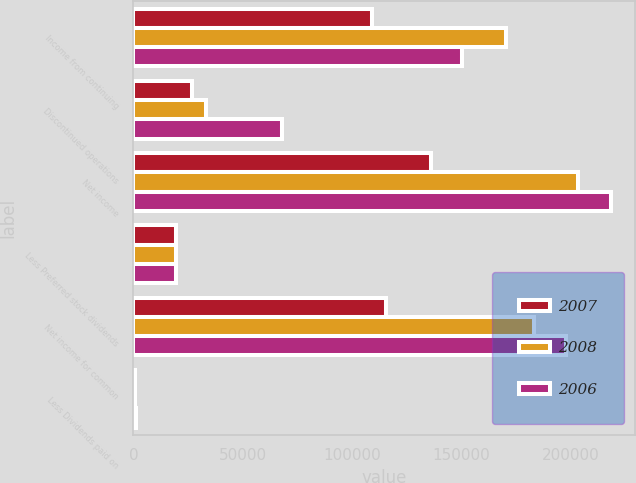Convert chart. <chart><loc_0><loc_0><loc_500><loc_500><stacked_bar_chart><ecel><fcel>Income from continuing<fcel>Discontinued operations<fcel>Net income<fcel>Less Preferred stock dividends<fcel>Net income for common<fcel>Less Dividends paid on<nl><fcel>2007<fcel>109204<fcel>26984<fcel>136188<fcel>19675<fcel>115780<fcel>733<nl><fcel>2008<fcel>170569<fcel>33082<fcel>203651<fcel>19675<fcel>183183<fcel>842<nl><fcel>2006<fcel>150441<fcel>68070<fcel>218511<fcel>19675<fcel>198022<fcel>978<nl></chart> 